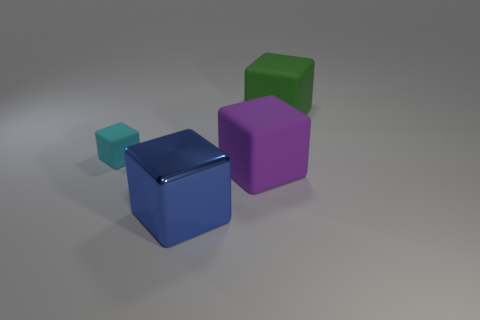Add 3 small blue shiny things. How many objects exist? 7 Subtract all small cubes. How many cubes are left? 3 Subtract 2 cubes. How many cubes are left? 2 Subtract all green blocks. How many blocks are left? 3 Subtract all cyan cubes. Subtract all blue cylinders. How many cubes are left? 3 Subtract 0 blue spheres. How many objects are left? 4 Subtract all tiny shiny things. Subtract all small rubber blocks. How many objects are left? 3 Add 2 small things. How many small things are left? 3 Add 1 large purple rubber blocks. How many large purple rubber blocks exist? 2 